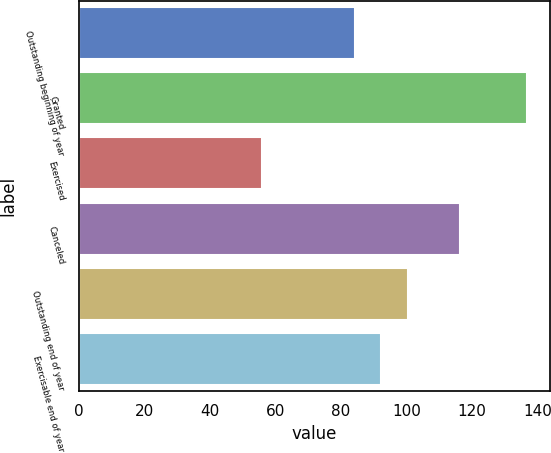<chart> <loc_0><loc_0><loc_500><loc_500><bar_chart><fcel>Outstanding beginning of year<fcel>Granted<fcel>Exercised<fcel>Canceled<fcel>Outstanding end of year<fcel>Exercisable end of year<nl><fcel>84.22<fcel>136.87<fcel>56<fcel>116.44<fcel>100.4<fcel>92.31<nl></chart> 